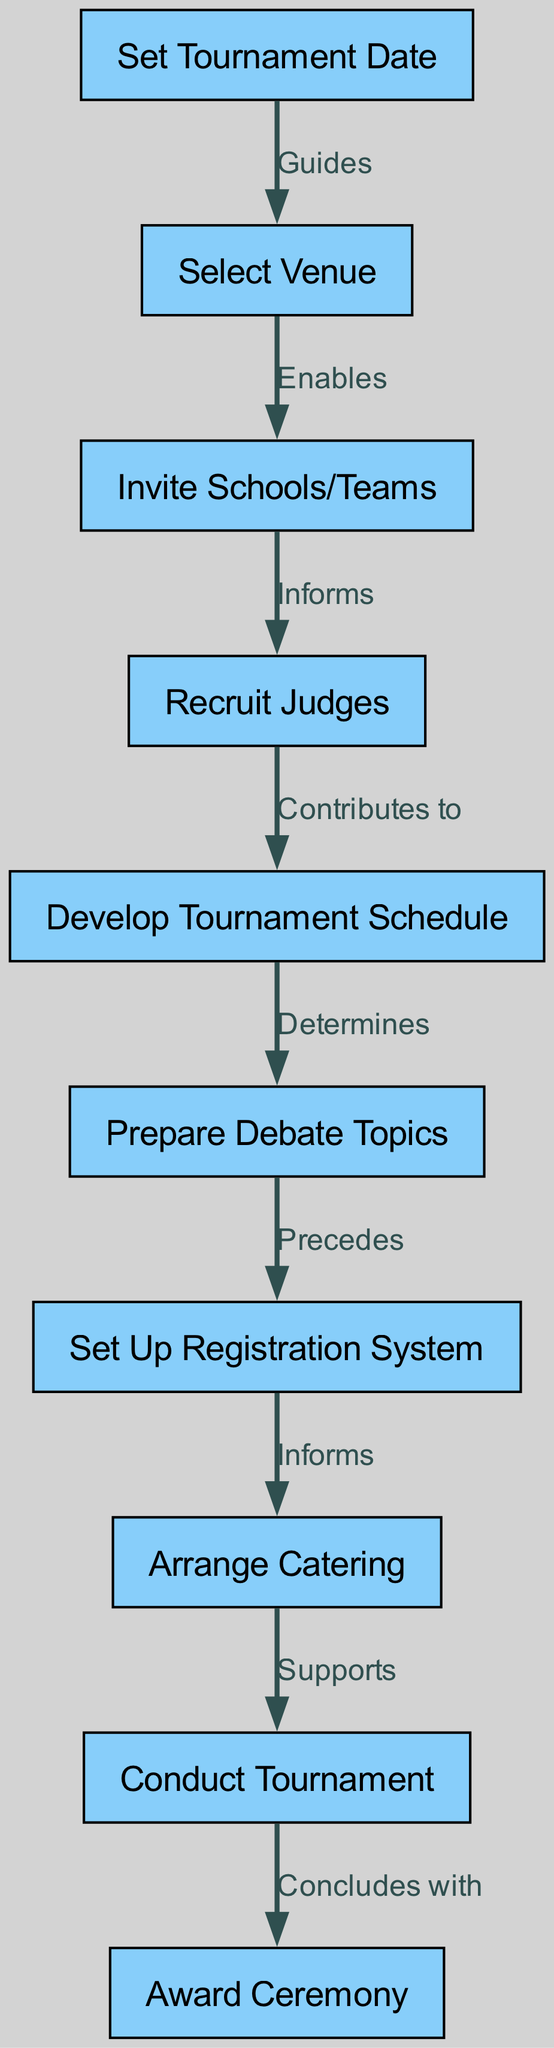What is the first stage in organizing a debate tournament? The first stage is labeled "Set Tournament Date," which directly indicates it is the initiation step in the organization process.
Answer: Set Tournament Date How many nodes are present in the flowchart? To find the number of nodes, we count the listed nodes in the data section. There are 10 nodes in total.
Answer: 10 What does the edge labeled "Enables" connect? The edge labeled "Enables" connects "Select Venue" and "Invite Schools/Teams," indicating that selecting a venue enables the invitation of teams.
Answer: Select Venue to Invite Schools/Teams Which node precedes "Set Up Registration System"? By reviewing the flow of the diagram, "Prepare Debate Topics" is the node that directly precedes "Set Up Registration System."
Answer: Prepare Debate Topics What relationship does "Arranged Catering" have with "Conduct Tournament"? The edge labeled "Supports" indicates a supportive relationship, meaning that catering arrangements directly support the execution of the tournament.
Answer: Supports What is the last stage of the tournament organization? The last stage is indicated by "Award Ceremony," which signifies the conclusion of the tournament activities.
Answer: Award Ceremony Which stage determines the debate topics? The stage that determines the debate topics is "Develop Tournament Schedule," as denoted by the relationship established in the diagram.
Answer: Develop Tournament Schedule How does "Recruit Judges" contribute to the tournament organization? "Recruit Judges" contributes to "Develop Tournament Schedule," indicating that the recruitment of judges plays a role in the scheduling process.
Answer: Contributes to What comes after "Conduct Tournament"? The direct progression after "Conduct Tournament" is "Award Ceremony," meaning that the tournament concludes with this ceremony.
Answer: Award Ceremony 